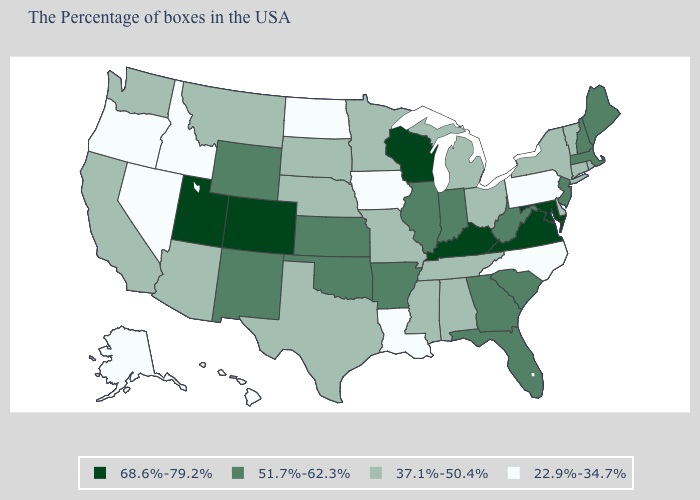Which states have the lowest value in the USA?
Concise answer only. Pennsylvania, North Carolina, Louisiana, Iowa, North Dakota, Idaho, Nevada, Oregon, Alaska, Hawaii. Name the states that have a value in the range 51.7%-62.3%?
Answer briefly. Maine, Massachusetts, New Hampshire, New Jersey, South Carolina, West Virginia, Florida, Georgia, Indiana, Illinois, Arkansas, Kansas, Oklahoma, Wyoming, New Mexico. Does Vermont have a higher value than Pennsylvania?
Be succinct. Yes. Name the states that have a value in the range 37.1%-50.4%?
Concise answer only. Rhode Island, Vermont, Connecticut, New York, Delaware, Ohio, Michigan, Alabama, Tennessee, Mississippi, Missouri, Minnesota, Nebraska, Texas, South Dakota, Montana, Arizona, California, Washington. Does Vermont have the lowest value in the USA?
Short answer required. No. Does Pennsylvania have the same value as Louisiana?
Give a very brief answer. Yes. What is the highest value in states that border Arizona?
Write a very short answer. 68.6%-79.2%. Name the states that have a value in the range 51.7%-62.3%?
Concise answer only. Maine, Massachusetts, New Hampshire, New Jersey, South Carolina, West Virginia, Florida, Georgia, Indiana, Illinois, Arkansas, Kansas, Oklahoma, Wyoming, New Mexico. Name the states that have a value in the range 68.6%-79.2%?
Write a very short answer. Maryland, Virginia, Kentucky, Wisconsin, Colorado, Utah. What is the value of Georgia?
Give a very brief answer. 51.7%-62.3%. Does Kentucky have the highest value in the USA?
Answer briefly. Yes. Name the states that have a value in the range 51.7%-62.3%?
Write a very short answer. Maine, Massachusetts, New Hampshire, New Jersey, South Carolina, West Virginia, Florida, Georgia, Indiana, Illinois, Arkansas, Kansas, Oklahoma, Wyoming, New Mexico. Does Tennessee have the highest value in the South?
Answer briefly. No. What is the value of New York?
Be succinct. 37.1%-50.4%. Name the states that have a value in the range 37.1%-50.4%?
Short answer required. Rhode Island, Vermont, Connecticut, New York, Delaware, Ohio, Michigan, Alabama, Tennessee, Mississippi, Missouri, Minnesota, Nebraska, Texas, South Dakota, Montana, Arizona, California, Washington. 